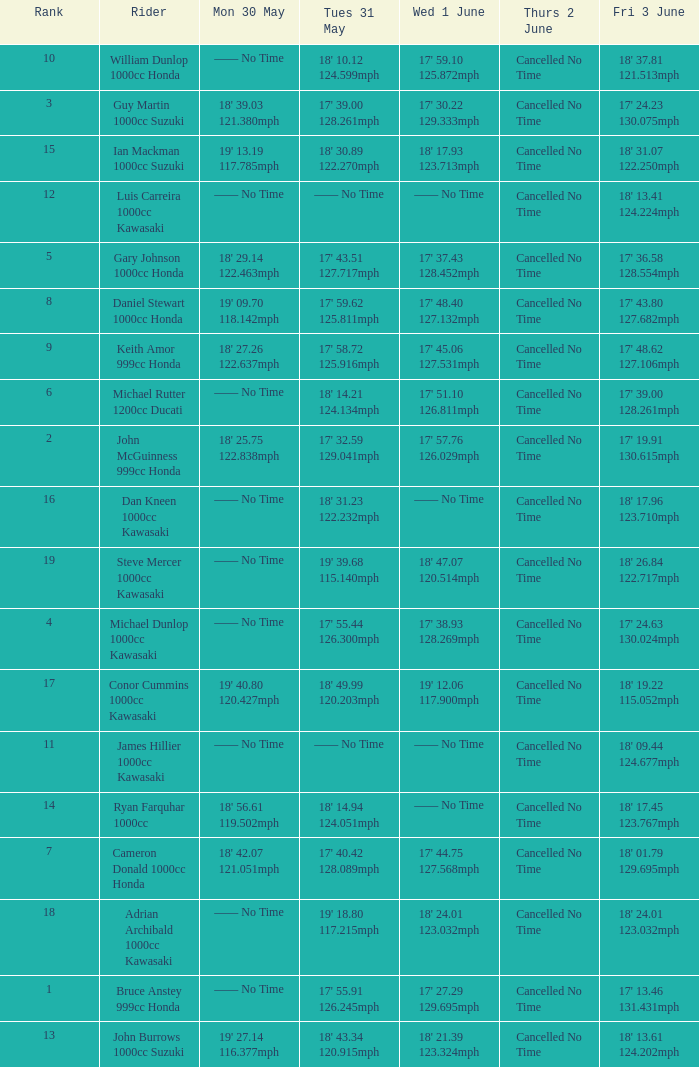What is the Mon 30 May time for the rider whose Fri 3 June time was 17' 13.46 131.431mph? —— No Time. Could you parse the entire table? {'header': ['Rank', 'Rider', 'Mon 30 May', 'Tues 31 May', 'Wed 1 June', 'Thurs 2 June', 'Fri 3 June'], 'rows': [['10', 'William Dunlop 1000cc Honda', '—— No Time', "18' 10.12 124.599mph", "17' 59.10 125.872mph", 'Cancelled No Time', "18' 37.81 121.513mph"], ['3', 'Guy Martin 1000cc Suzuki', "18' 39.03 121.380mph", "17' 39.00 128.261mph", "17' 30.22 129.333mph", 'Cancelled No Time', "17' 24.23 130.075mph"], ['15', 'Ian Mackman 1000cc Suzuki', "19' 13.19 117.785mph", "18' 30.89 122.270mph", "18' 17.93 123.713mph", 'Cancelled No Time', "18' 31.07 122.250mph"], ['12', 'Luis Carreira 1000cc Kawasaki', '—— No Time', '—— No Time', '—— No Time', 'Cancelled No Time', "18' 13.41 124.224mph"], ['5', 'Gary Johnson 1000cc Honda', "18' 29.14 122.463mph", "17' 43.51 127.717mph", "17' 37.43 128.452mph", 'Cancelled No Time', "17' 36.58 128.554mph"], ['8', 'Daniel Stewart 1000cc Honda', "19' 09.70 118.142mph", "17' 59.62 125.811mph", "17' 48.40 127.132mph", 'Cancelled No Time', "17' 43.80 127.682mph"], ['9', 'Keith Amor 999cc Honda', "18' 27.26 122.637mph", "17' 58.72 125.916mph", "17' 45.06 127.531mph", 'Cancelled No Time', "17' 48.62 127.106mph"], ['6', 'Michael Rutter 1200cc Ducati', '—— No Time', "18' 14.21 124.134mph", "17' 51.10 126.811mph", 'Cancelled No Time', "17' 39.00 128.261mph"], ['2', 'John McGuinness 999cc Honda', "18' 25.75 122.838mph", "17' 32.59 129.041mph", "17' 57.76 126.029mph", 'Cancelled No Time', "17' 19.91 130.615mph"], ['16', 'Dan Kneen 1000cc Kawasaki', '—— No Time', "18' 31.23 122.232mph", '—— No Time', 'Cancelled No Time', "18' 17.96 123.710mph"], ['19', 'Steve Mercer 1000cc Kawasaki', '—— No Time', "19' 39.68 115.140mph", "18' 47.07 120.514mph", 'Cancelled No Time', "18' 26.84 122.717mph"], ['4', 'Michael Dunlop 1000cc Kawasaki', '—— No Time', "17' 55.44 126.300mph", "17' 38.93 128.269mph", 'Cancelled No Time', "17' 24.63 130.024mph"], ['17', 'Conor Cummins 1000cc Kawasaki', "19' 40.80 120.427mph", "18' 49.99 120.203mph", "19' 12.06 117.900mph", 'Cancelled No Time', "18' 19.22 115.052mph"], ['11', 'James Hillier 1000cc Kawasaki', '—— No Time', '—— No Time', '—— No Time', 'Cancelled No Time', "18' 09.44 124.677mph"], ['14', 'Ryan Farquhar 1000cc', "18' 56.61 119.502mph", "18' 14.94 124.051mph", '—— No Time', 'Cancelled No Time', "18' 17.45 123.767mph"], ['7', 'Cameron Donald 1000cc Honda', "18' 42.07 121.051mph", "17' 40.42 128.089mph", "17' 44.75 127.568mph", 'Cancelled No Time', "18' 01.79 129.695mph"], ['18', 'Adrian Archibald 1000cc Kawasaki', '—— No Time', "19' 18.80 117.215mph", "18' 24.01 123.032mph", 'Cancelled No Time', "18' 24.01 123.032mph"], ['1', 'Bruce Anstey 999cc Honda', '—— No Time', "17' 55.91 126.245mph", "17' 27.29 129.695mph", 'Cancelled No Time', "17' 13.46 131.431mph"], ['13', 'John Burrows 1000cc Suzuki', "19' 27.14 116.377mph", "18' 43.34 120.915mph", "18' 21.39 123.324mph", 'Cancelled No Time', "18' 13.61 124.202mph"]]} 